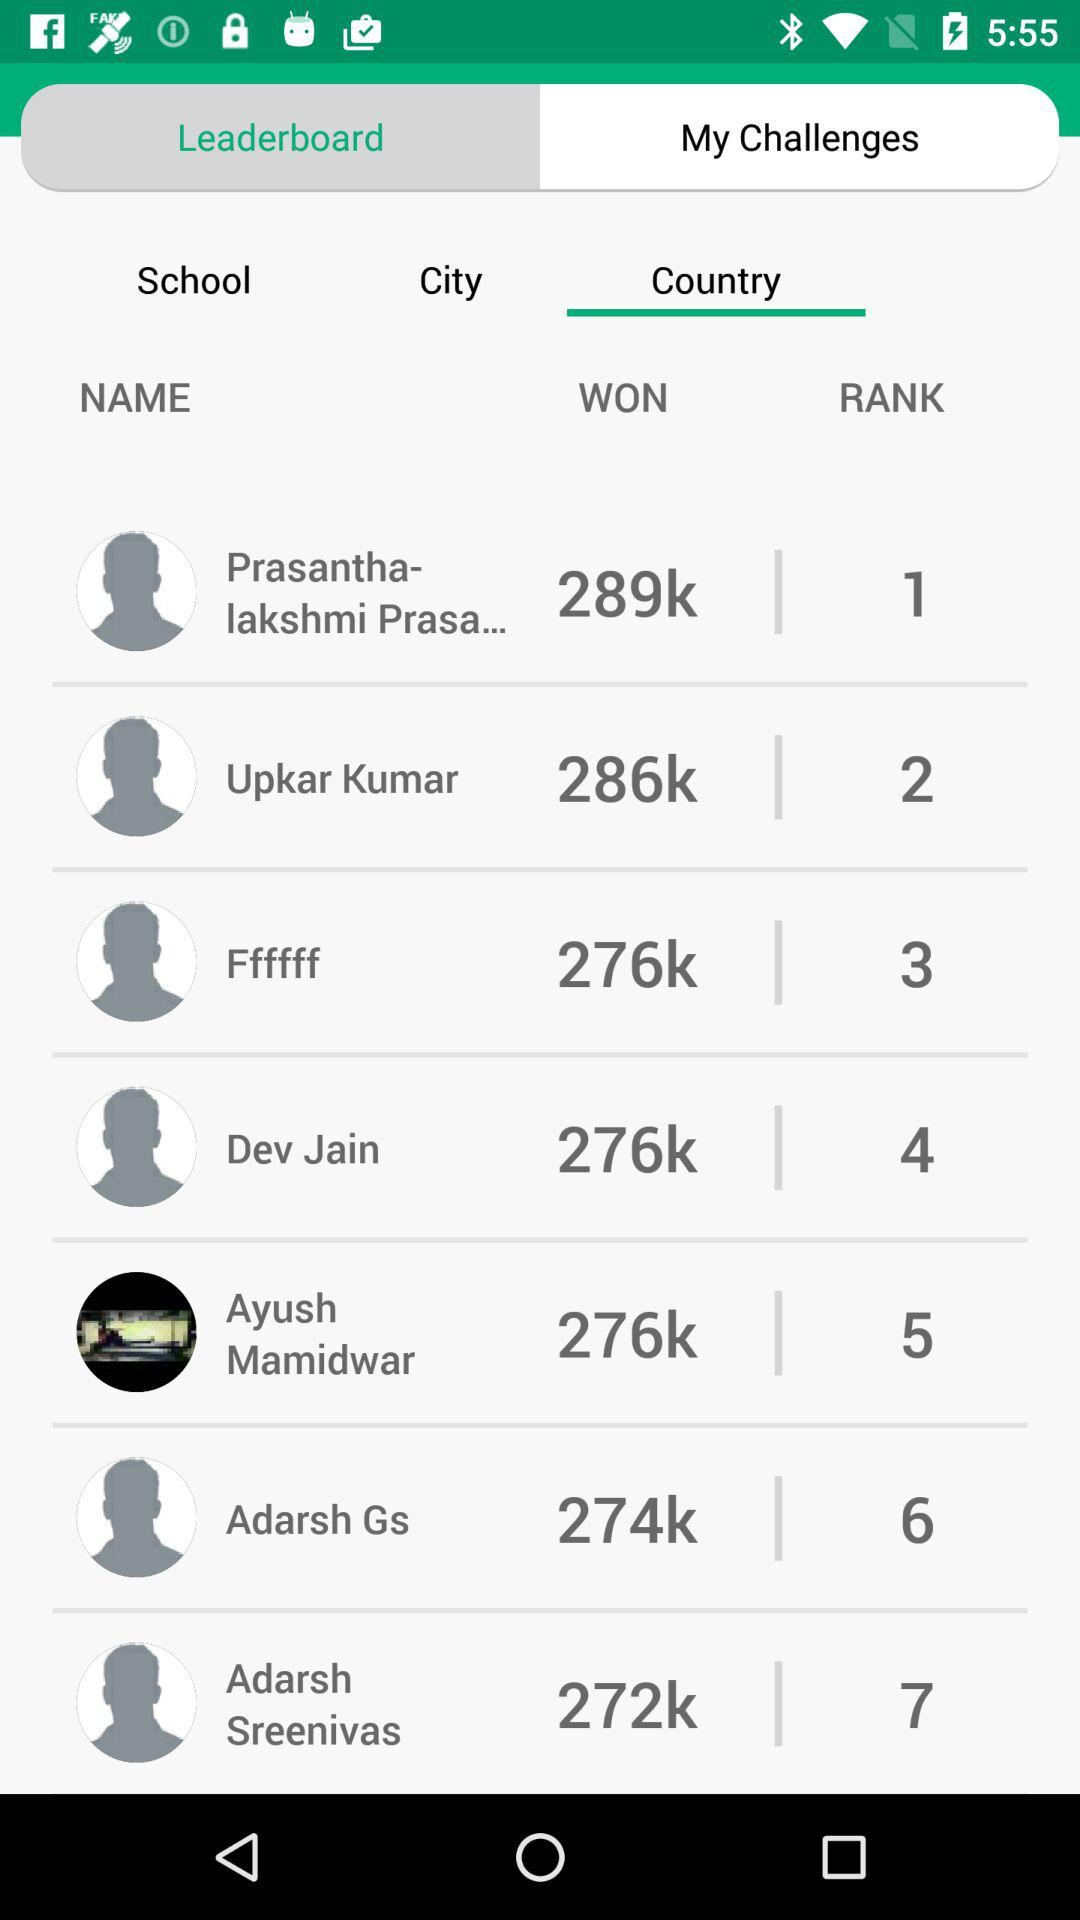How many more points does the person in 1st place have than the person in 7th place?
Answer the question using a single word or phrase. 17 